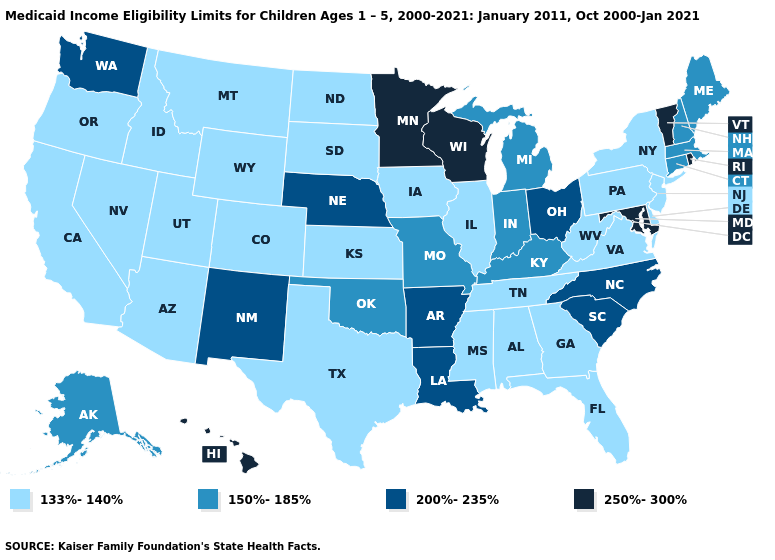Which states have the lowest value in the USA?
Answer briefly. Alabama, Arizona, California, Colorado, Delaware, Florida, Georgia, Idaho, Illinois, Iowa, Kansas, Mississippi, Montana, Nevada, New Jersey, New York, North Dakota, Oregon, Pennsylvania, South Dakota, Tennessee, Texas, Utah, Virginia, West Virginia, Wyoming. Which states have the lowest value in the MidWest?
Answer briefly. Illinois, Iowa, Kansas, North Dakota, South Dakota. Among the states that border Louisiana , which have the lowest value?
Quick response, please. Mississippi, Texas. Is the legend a continuous bar?
Be succinct. No. Does Minnesota have the highest value in the USA?
Write a very short answer. Yes. How many symbols are there in the legend?
Answer briefly. 4. Which states have the lowest value in the USA?
Be succinct. Alabama, Arizona, California, Colorado, Delaware, Florida, Georgia, Idaho, Illinois, Iowa, Kansas, Mississippi, Montana, Nevada, New Jersey, New York, North Dakota, Oregon, Pennsylvania, South Dakota, Tennessee, Texas, Utah, Virginia, West Virginia, Wyoming. Does Oklahoma have the lowest value in the USA?
Answer briefly. No. Does Maine have the highest value in the USA?
Keep it brief. No. What is the highest value in the West ?
Give a very brief answer. 250%-300%. What is the highest value in states that border South Carolina?
Answer briefly. 200%-235%. What is the value of Alabama?
Short answer required. 133%-140%. Name the states that have a value in the range 250%-300%?
Concise answer only. Hawaii, Maryland, Minnesota, Rhode Island, Vermont, Wisconsin. Does the first symbol in the legend represent the smallest category?
Concise answer only. Yes. What is the lowest value in the USA?
Be succinct. 133%-140%. 